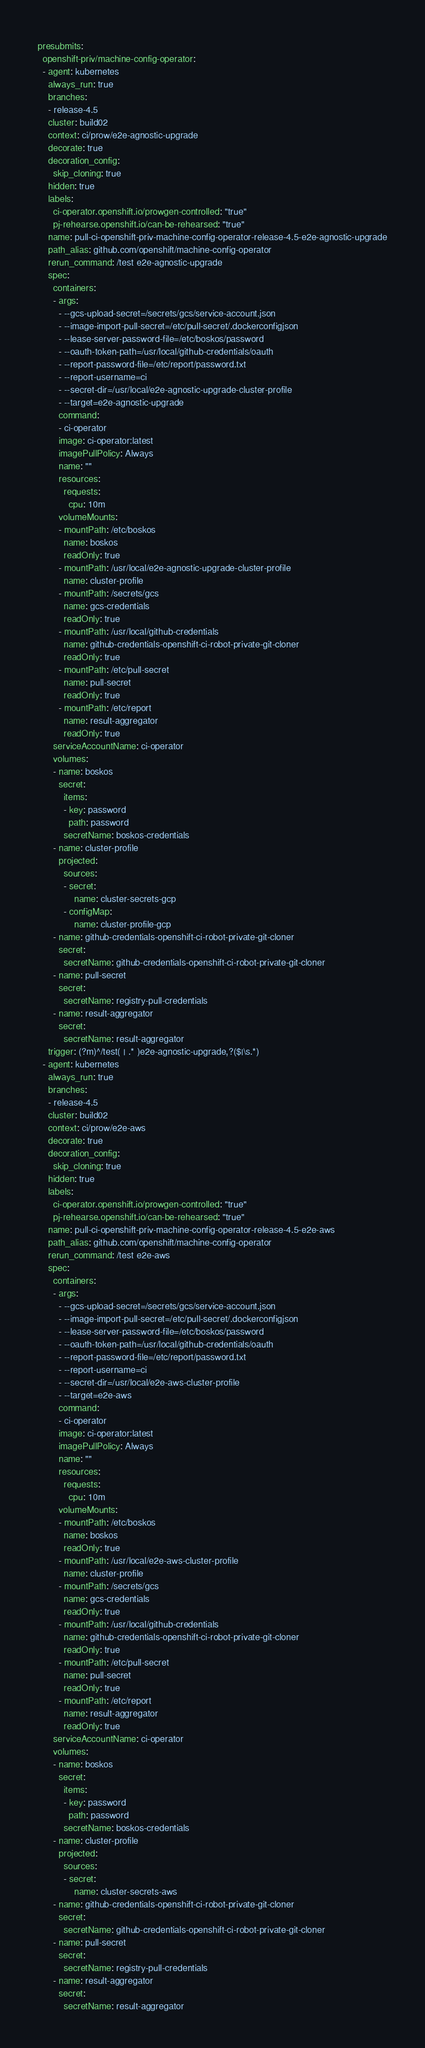Convert code to text. <code><loc_0><loc_0><loc_500><loc_500><_YAML_>presubmits:
  openshift-priv/machine-config-operator:
  - agent: kubernetes
    always_run: true
    branches:
    - release-4.5
    cluster: build02
    context: ci/prow/e2e-agnostic-upgrade
    decorate: true
    decoration_config:
      skip_cloning: true
    hidden: true
    labels:
      ci-operator.openshift.io/prowgen-controlled: "true"
      pj-rehearse.openshift.io/can-be-rehearsed: "true"
    name: pull-ci-openshift-priv-machine-config-operator-release-4.5-e2e-agnostic-upgrade
    path_alias: github.com/openshift/machine-config-operator
    rerun_command: /test e2e-agnostic-upgrade
    spec:
      containers:
      - args:
        - --gcs-upload-secret=/secrets/gcs/service-account.json
        - --image-import-pull-secret=/etc/pull-secret/.dockerconfigjson
        - --lease-server-password-file=/etc/boskos/password
        - --oauth-token-path=/usr/local/github-credentials/oauth
        - --report-password-file=/etc/report/password.txt
        - --report-username=ci
        - --secret-dir=/usr/local/e2e-agnostic-upgrade-cluster-profile
        - --target=e2e-agnostic-upgrade
        command:
        - ci-operator
        image: ci-operator:latest
        imagePullPolicy: Always
        name: ""
        resources:
          requests:
            cpu: 10m
        volumeMounts:
        - mountPath: /etc/boskos
          name: boskos
          readOnly: true
        - mountPath: /usr/local/e2e-agnostic-upgrade-cluster-profile
          name: cluster-profile
        - mountPath: /secrets/gcs
          name: gcs-credentials
          readOnly: true
        - mountPath: /usr/local/github-credentials
          name: github-credentials-openshift-ci-robot-private-git-cloner
          readOnly: true
        - mountPath: /etc/pull-secret
          name: pull-secret
          readOnly: true
        - mountPath: /etc/report
          name: result-aggregator
          readOnly: true
      serviceAccountName: ci-operator
      volumes:
      - name: boskos
        secret:
          items:
          - key: password
            path: password
          secretName: boskos-credentials
      - name: cluster-profile
        projected:
          sources:
          - secret:
              name: cluster-secrets-gcp
          - configMap:
              name: cluster-profile-gcp
      - name: github-credentials-openshift-ci-robot-private-git-cloner
        secret:
          secretName: github-credentials-openshift-ci-robot-private-git-cloner
      - name: pull-secret
        secret:
          secretName: registry-pull-credentials
      - name: result-aggregator
        secret:
          secretName: result-aggregator
    trigger: (?m)^/test( | .* )e2e-agnostic-upgrade,?($|\s.*)
  - agent: kubernetes
    always_run: true
    branches:
    - release-4.5
    cluster: build02
    context: ci/prow/e2e-aws
    decorate: true
    decoration_config:
      skip_cloning: true
    hidden: true
    labels:
      ci-operator.openshift.io/prowgen-controlled: "true"
      pj-rehearse.openshift.io/can-be-rehearsed: "true"
    name: pull-ci-openshift-priv-machine-config-operator-release-4.5-e2e-aws
    path_alias: github.com/openshift/machine-config-operator
    rerun_command: /test e2e-aws
    spec:
      containers:
      - args:
        - --gcs-upload-secret=/secrets/gcs/service-account.json
        - --image-import-pull-secret=/etc/pull-secret/.dockerconfigjson
        - --lease-server-password-file=/etc/boskos/password
        - --oauth-token-path=/usr/local/github-credentials/oauth
        - --report-password-file=/etc/report/password.txt
        - --report-username=ci
        - --secret-dir=/usr/local/e2e-aws-cluster-profile
        - --target=e2e-aws
        command:
        - ci-operator
        image: ci-operator:latest
        imagePullPolicy: Always
        name: ""
        resources:
          requests:
            cpu: 10m
        volumeMounts:
        - mountPath: /etc/boskos
          name: boskos
          readOnly: true
        - mountPath: /usr/local/e2e-aws-cluster-profile
          name: cluster-profile
        - mountPath: /secrets/gcs
          name: gcs-credentials
          readOnly: true
        - mountPath: /usr/local/github-credentials
          name: github-credentials-openshift-ci-robot-private-git-cloner
          readOnly: true
        - mountPath: /etc/pull-secret
          name: pull-secret
          readOnly: true
        - mountPath: /etc/report
          name: result-aggregator
          readOnly: true
      serviceAccountName: ci-operator
      volumes:
      - name: boskos
        secret:
          items:
          - key: password
            path: password
          secretName: boskos-credentials
      - name: cluster-profile
        projected:
          sources:
          - secret:
              name: cluster-secrets-aws
      - name: github-credentials-openshift-ci-robot-private-git-cloner
        secret:
          secretName: github-credentials-openshift-ci-robot-private-git-cloner
      - name: pull-secret
        secret:
          secretName: registry-pull-credentials
      - name: result-aggregator
        secret:
          secretName: result-aggregator</code> 